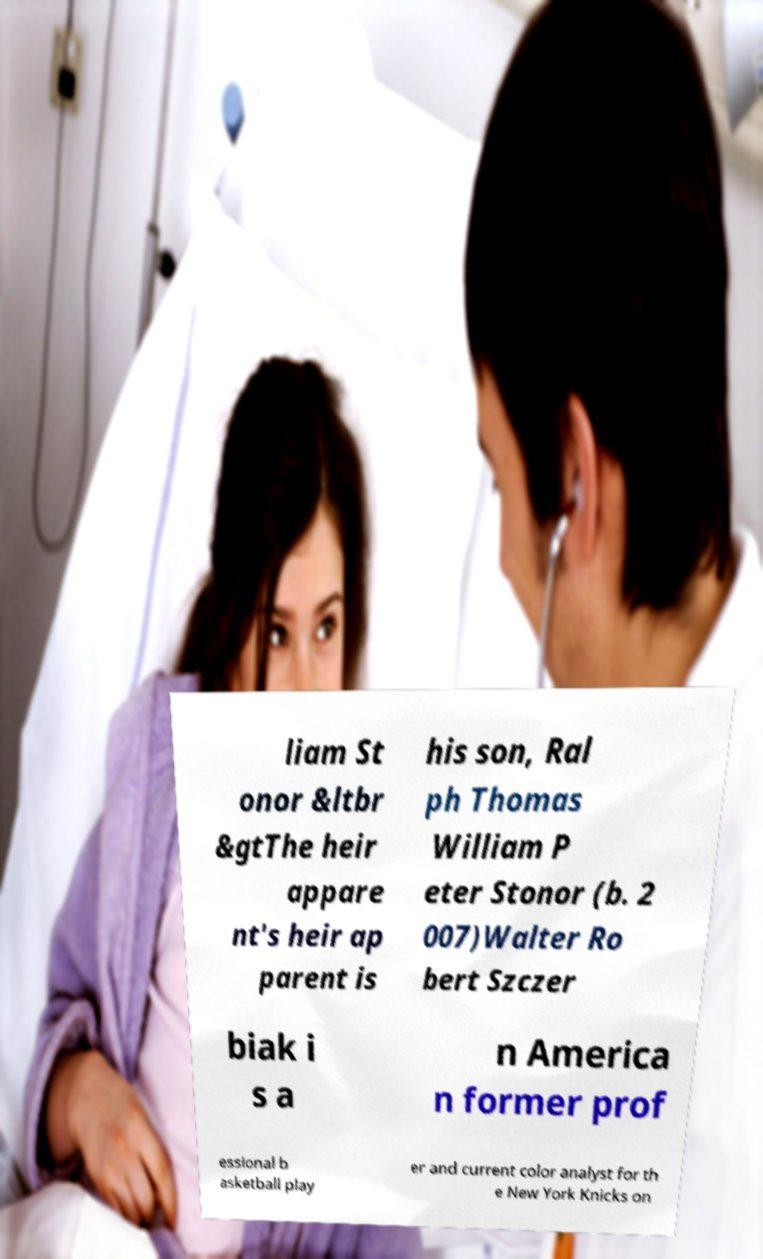Please read and relay the text visible in this image. What does it say? liam St onor &ltbr &gtThe heir appare nt's heir ap parent is his son, Ral ph Thomas William P eter Stonor (b. 2 007)Walter Ro bert Szczer biak i s a n America n former prof essional b asketball play er and current color analyst for th e New York Knicks on 